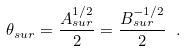Convert formula to latex. <formula><loc_0><loc_0><loc_500><loc_500>\theta _ { s u r } = \frac { A _ { s u r } ^ { 1 / 2 } } { 2 } = \frac { B _ { s u r } ^ { - 1 / 2 } } { 2 } \ .</formula> 